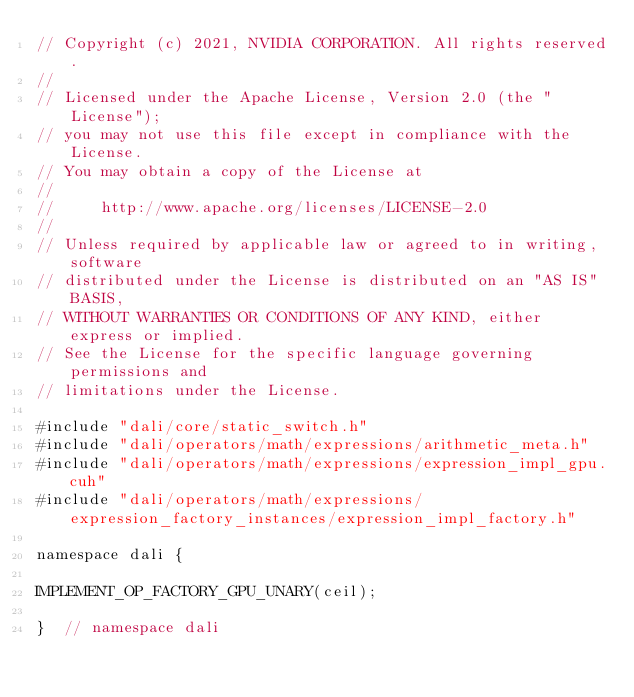Convert code to text. <code><loc_0><loc_0><loc_500><loc_500><_Cuda_>// Copyright (c) 2021, NVIDIA CORPORATION. All rights reserved.
//
// Licensed under the Apache License, Version 2.0 (the "License");
// you may not use this file except in compliance with the License.
// You may obtain a copy of the License at
//
//     http://www.apache.org/licenses/LICENSE-2.0
//
// Unless required by applicable law or agreed to in writing, software
// distributed under the License is distributed on an "AS IS" BASIS,
// WITHOUT WARRANTIES OR CONDITIONS OF ANY KIND, either express or implied.
// See the License for the specific language governing permissions and
// limitations under the License.

#include "dali/core/static_switch.h"
#include "dali/operators/math/expressions/arithmetic_meta.h"
#include "dali/operators/math/expressions/expression_impl_gpu.cuh"
#include "dali/operators/math/expressions/expression_factory_instances/expression_impl_factory.h"

namespace dali {

IMPLEMENT_OP_FACTORY_GPU_UNARY(ceil);

}  // namespace dali
</code> 